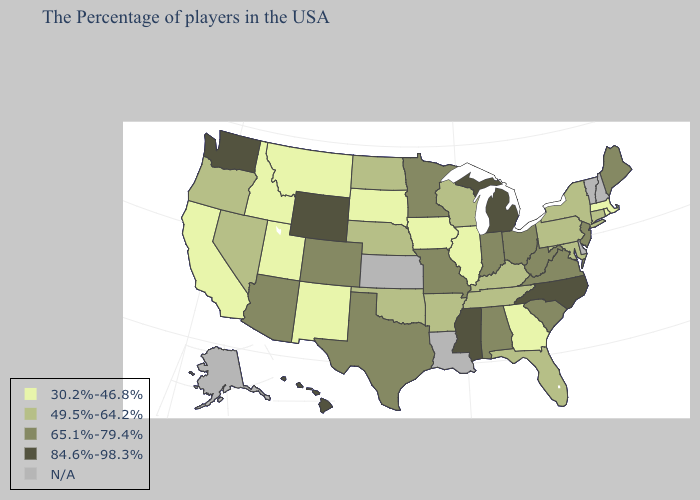Name the states that have a value in the range 65.1%-79.4%?
Concise answer only. Maine, New Jersey, Virginia, South Carolina, West Virginia, Ohio, Indiana, Alabama, Missouri, Minnesota, Texas, Colorado, Arizona. Does South Carolina have the lowest value in the South?
Concise answer only. No. Among the states that border Indiana , does Michigan have the highest value?
Short answer required. Yes. Does Pennsylvania have the highest value in the Northeast?
Quick response, please. No. What is the value of Massachusetts?
Quick response, please. 30.2%-46.8%. Is the legend a continuous bar?
Write a very short answer. No. Name the states that have a value in the range 49.5%-64.2%?
Be succinct. Connecticut, New York, Maryland, Pennsylvania, Florida, Kentucky, Tennessee, Wisconsin, Arkansas, Nebraska, Oklahoma, North Dakota, Nevada, Oregon. Name the states that have a value in the range 49.5%-64.2%?
Concise answer only. Connecticut, New York, Maryland, Pennsylvania, Florida, Kentucky, Tennessee, Wisconsin, Arkansas, Nebraska, Oklahoma, North Dakota, Nevada, Oregon. What is the highest value in states that border South Carolina?
Concise answer only. 84.6%-98.3%. Name the states that have a value in the range 84.6%-98.3%?
Give a very brief answer. North Carolina, Michigan, Mississippi, Wyoming, Washington, Hawaii. Name the states that have a value in the range 84.6%-98.3%?
Answer briefly. North Carolina, Michigan, Mississippi, Wyoming, Washington, Hawaii. Name the states that have a value in the range 30.2%-46.8%?
Keep it brief. Massachusetts, Rhode Island, Georgia, Illinois, Iowa, South Dakota, New Mexico, Utah, Montana, Idaho, California. Which states have the highest value in the USA?
Answer briefly. North Carolina, Michigan, Mississippi, Wyoming, Washington, Hawaii. 